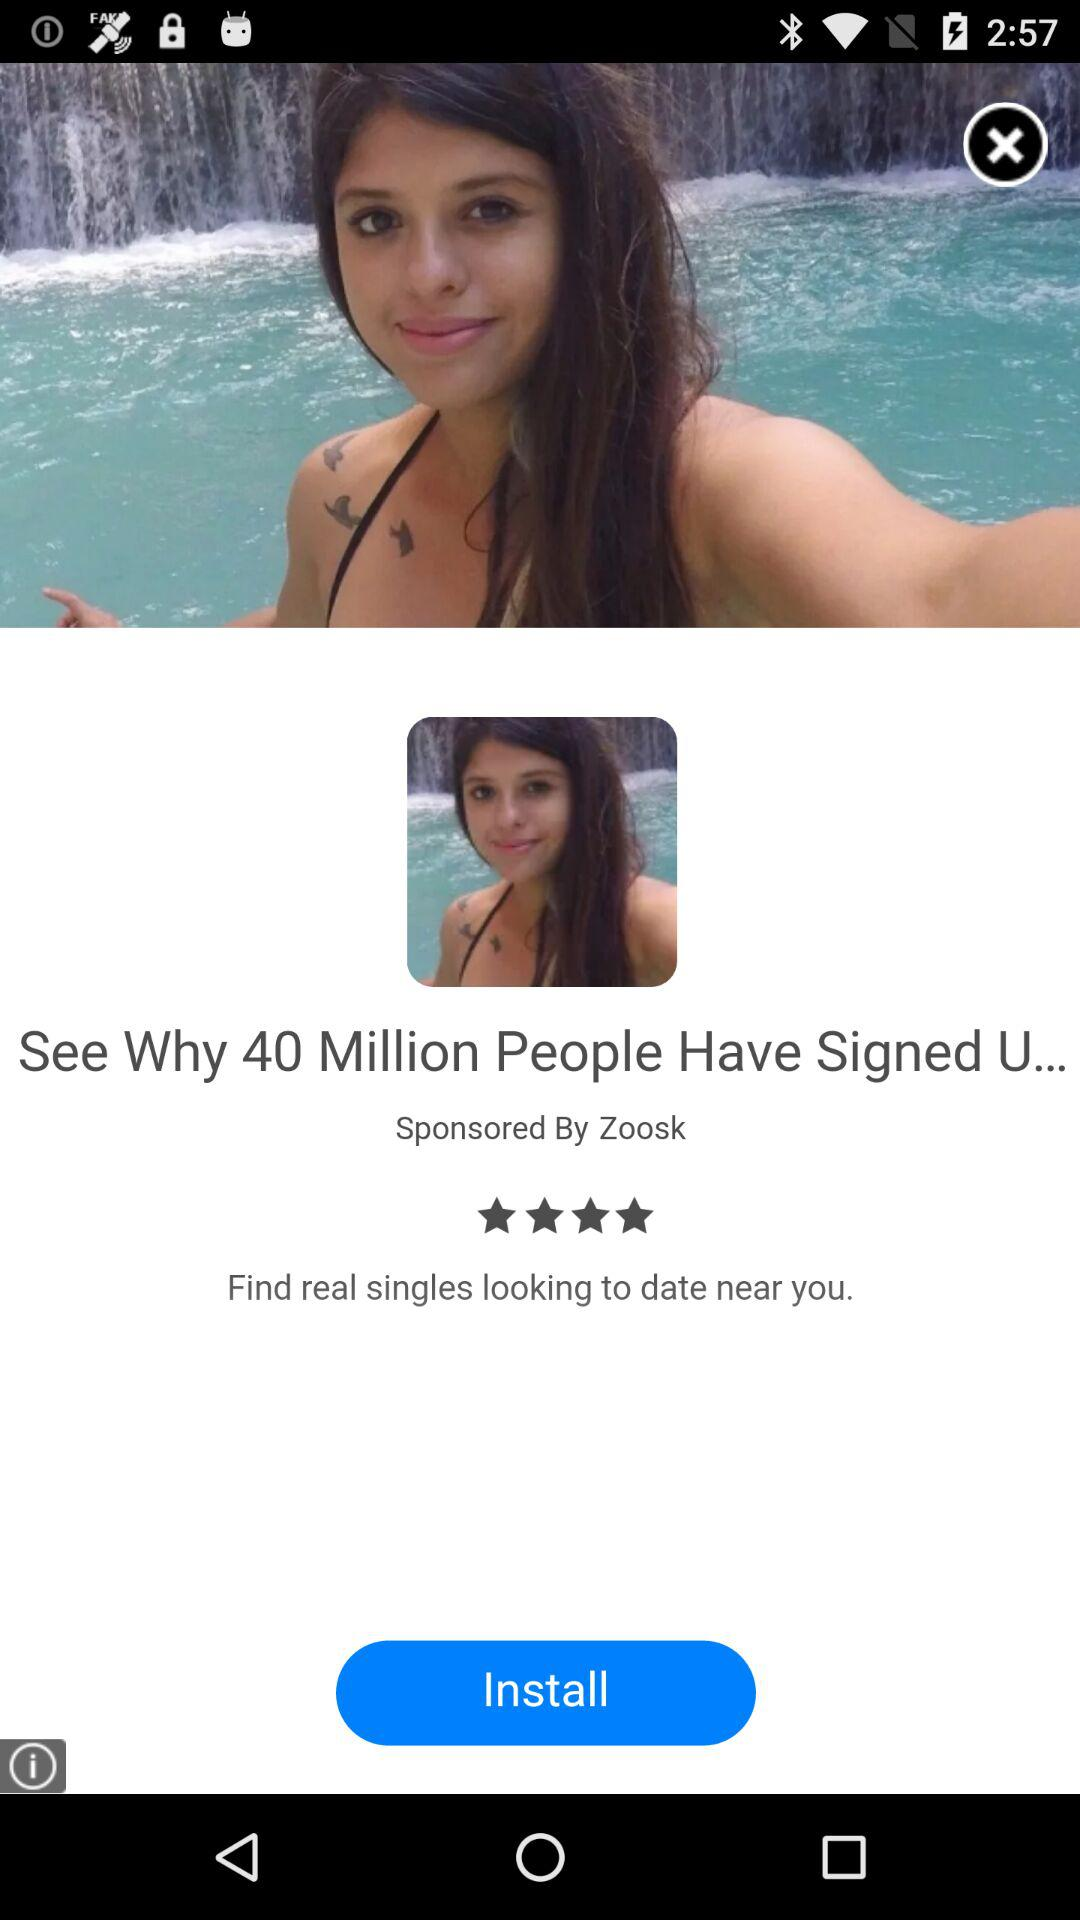How many people have signed in? The people that have signed in are 40 million. 